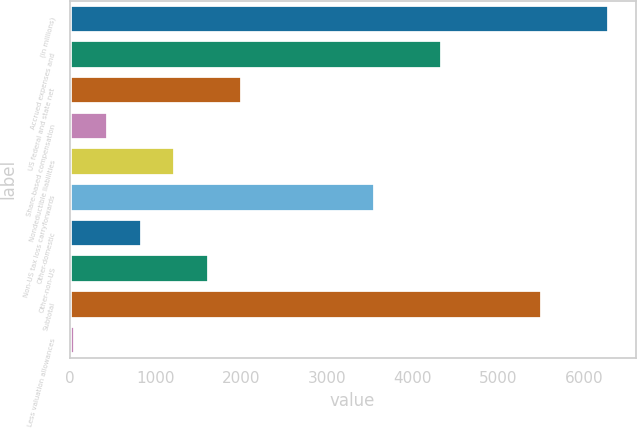<chart> <loc_0><loc_0><loc_500><loc_500><bar_chart><fcel>(in millions)<fcel>Accrued expenses and<fcel>US federal and state net<fcel>Share-based compensation<fcel>Nondeductible liabilities<fcel>Non-US tax loss carryforwards<fcel>Other-domestic<fcel>Other-non-US<fcel>Subtotal<fcel>Less valuation allowances<nl><fcel>6288<fcel>4343<fcel>2009<fcel>453<fcel>1231<fcel>3565<fcel>842<fcel>1620<fcel>5510<fcel>64<nl></chart> 